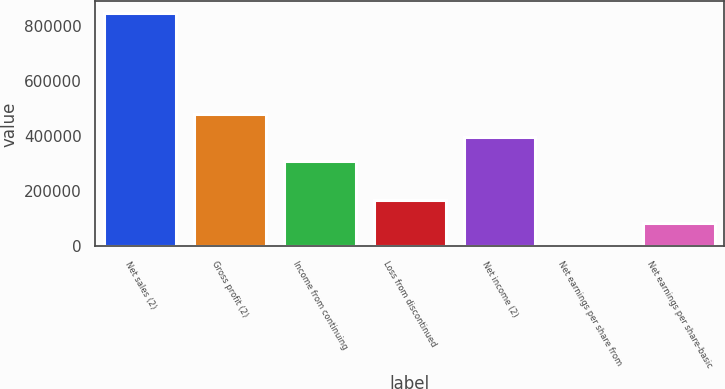<chart> <loc_0><loc_0><loc_500><loc_500><bar_chart><fcel>Net sales (2)<fcel>Gross profit (2)<fcel>Income from continuing<fcel>Loss from discontinued<fcel>Net income (2)<fcel>Net earnings per share from<fcel>Net earnings per share-basic<nl><fcel>847960<fcel>481602<fcel>312011<fcel>169596<fcel>396807<fcel>4.6<fcel>84800.1<nl></chart> 